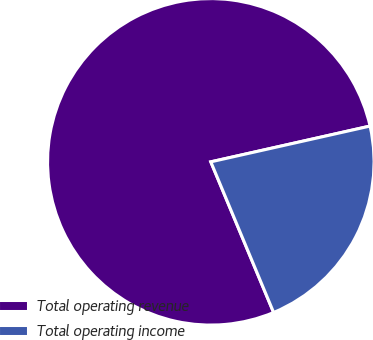Convert chart to OTSL. <chart><loc_0><loc_0><loc_500><loc_500><pie_chart><fcel>Total operating revenue<fcel>Total operating income<nl><fcel>77.77%<fcel>22.23%<nl></chart> 